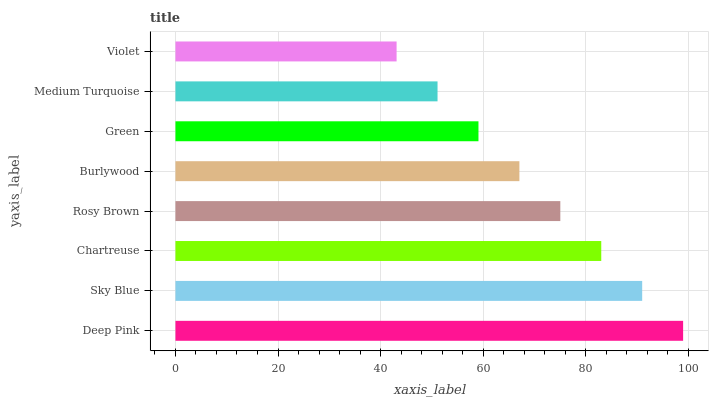Is Violet the minimum?
Answer yes or no. Yes. Is Deep Pink the maximum?
Answer yes or no. Yes. Is Sky Blue the minimum?
Answer yes or no. No. Is Sky Blue the maximum?
Answer yes or no. No. Is Deep Pink greater than Sky Blue?
Answer yes or no. Yes. Is Sky Blue less than Deep Pink?
Answer yes or no. Yes. Is Sky Blue greater than Deep Pink?
Answer yes or no. No. Is Deep Pink less than Sky Blue?
Answer yes or no. No. Is Rosy Brown the high median?
Answer yes or no. Yes. Is Burlywood the low median?
Answer yes or no. Yes. Is Green the high median?
Answer yes or no. No. Is Medium Turquoise the low median?
Answer yes or no. No. 